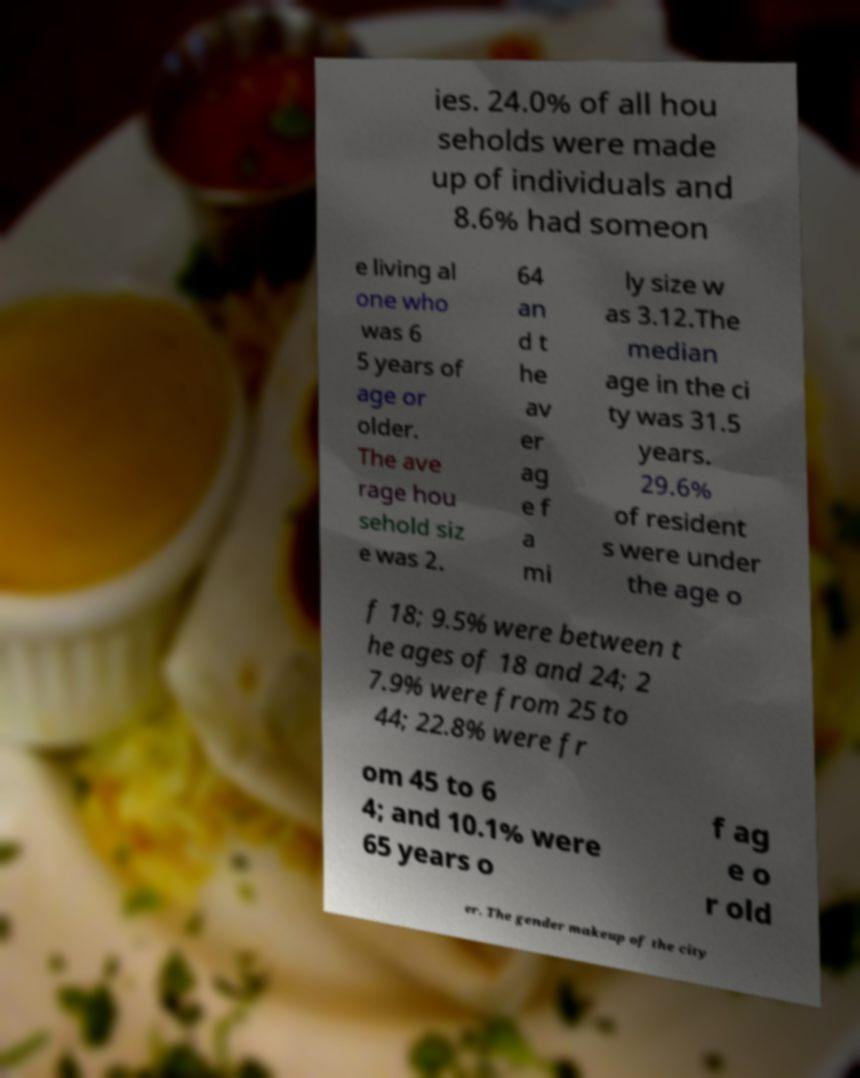There's text embedded in this image that I need extracted. Can you transcribe it verbatim? ies. 24.0% of all hou seholds were made up of individuals and 8.6% had someon e living al one who was 6 5 years of age or older. The ave rage hou sehold siz e was 2. 64 an d t he av er ag e f a mi ly size w as 3.12.The median age in the ci ty was 31.5 years. 29.6% of resident s were under the age o f 18; 9.5% were between t he ages of 18 and 24; 2 7.9% were from 25 to 44; 22.8% were fr om 45 to 6 4; and 10.1% were 65 years o f ag e o r old er. The gender makeup of the city 